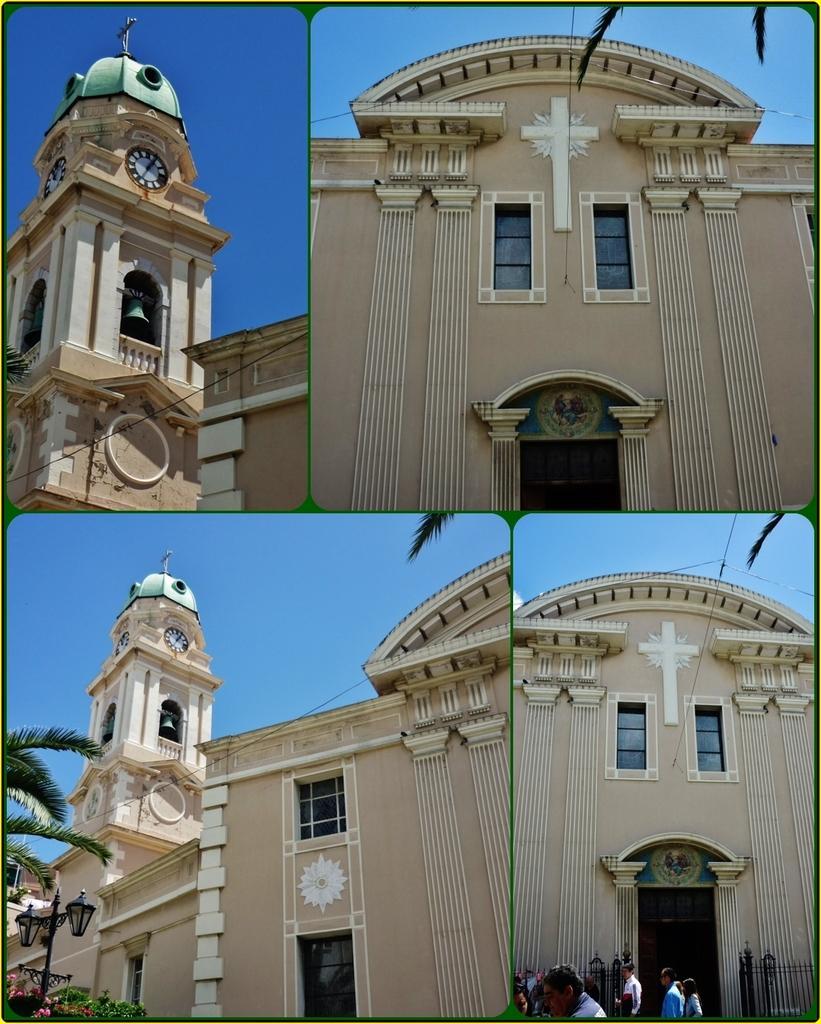Can you describe this image briefly? Here we can see collage pictures, in this we can see a building, tree, plants, lights and few people. 